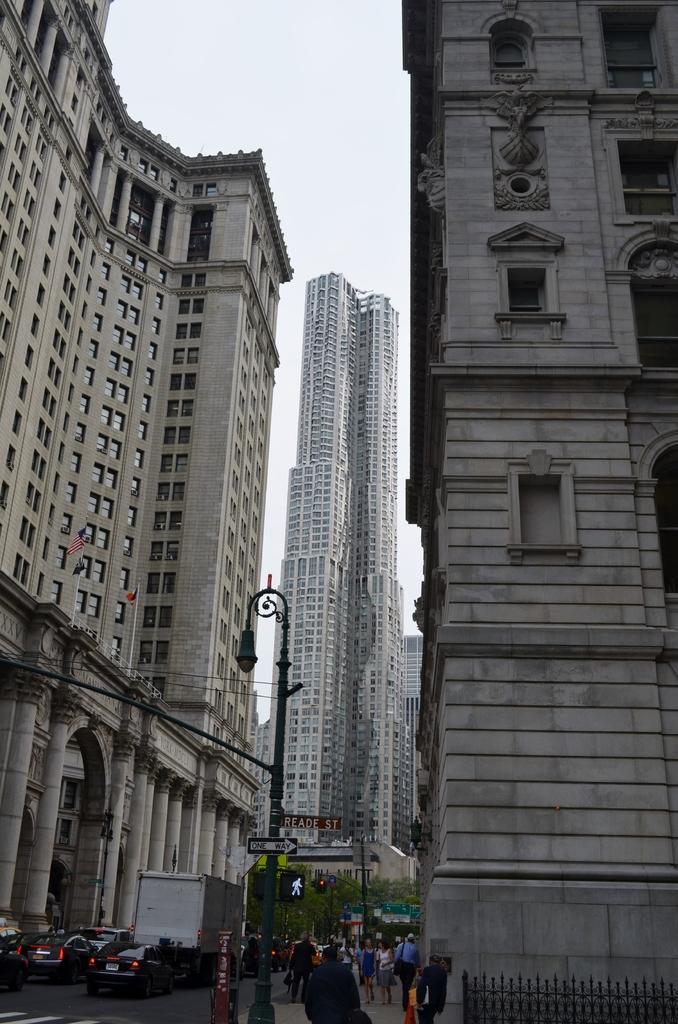Please provide a concise description of this image. In this image we can see many buildings with windows. At the bottom there is a light pole. Also there are many people and there is a road with many vehicles. In the back there are trees. Also there is a traffic signal with pole. In the background there is sky. 